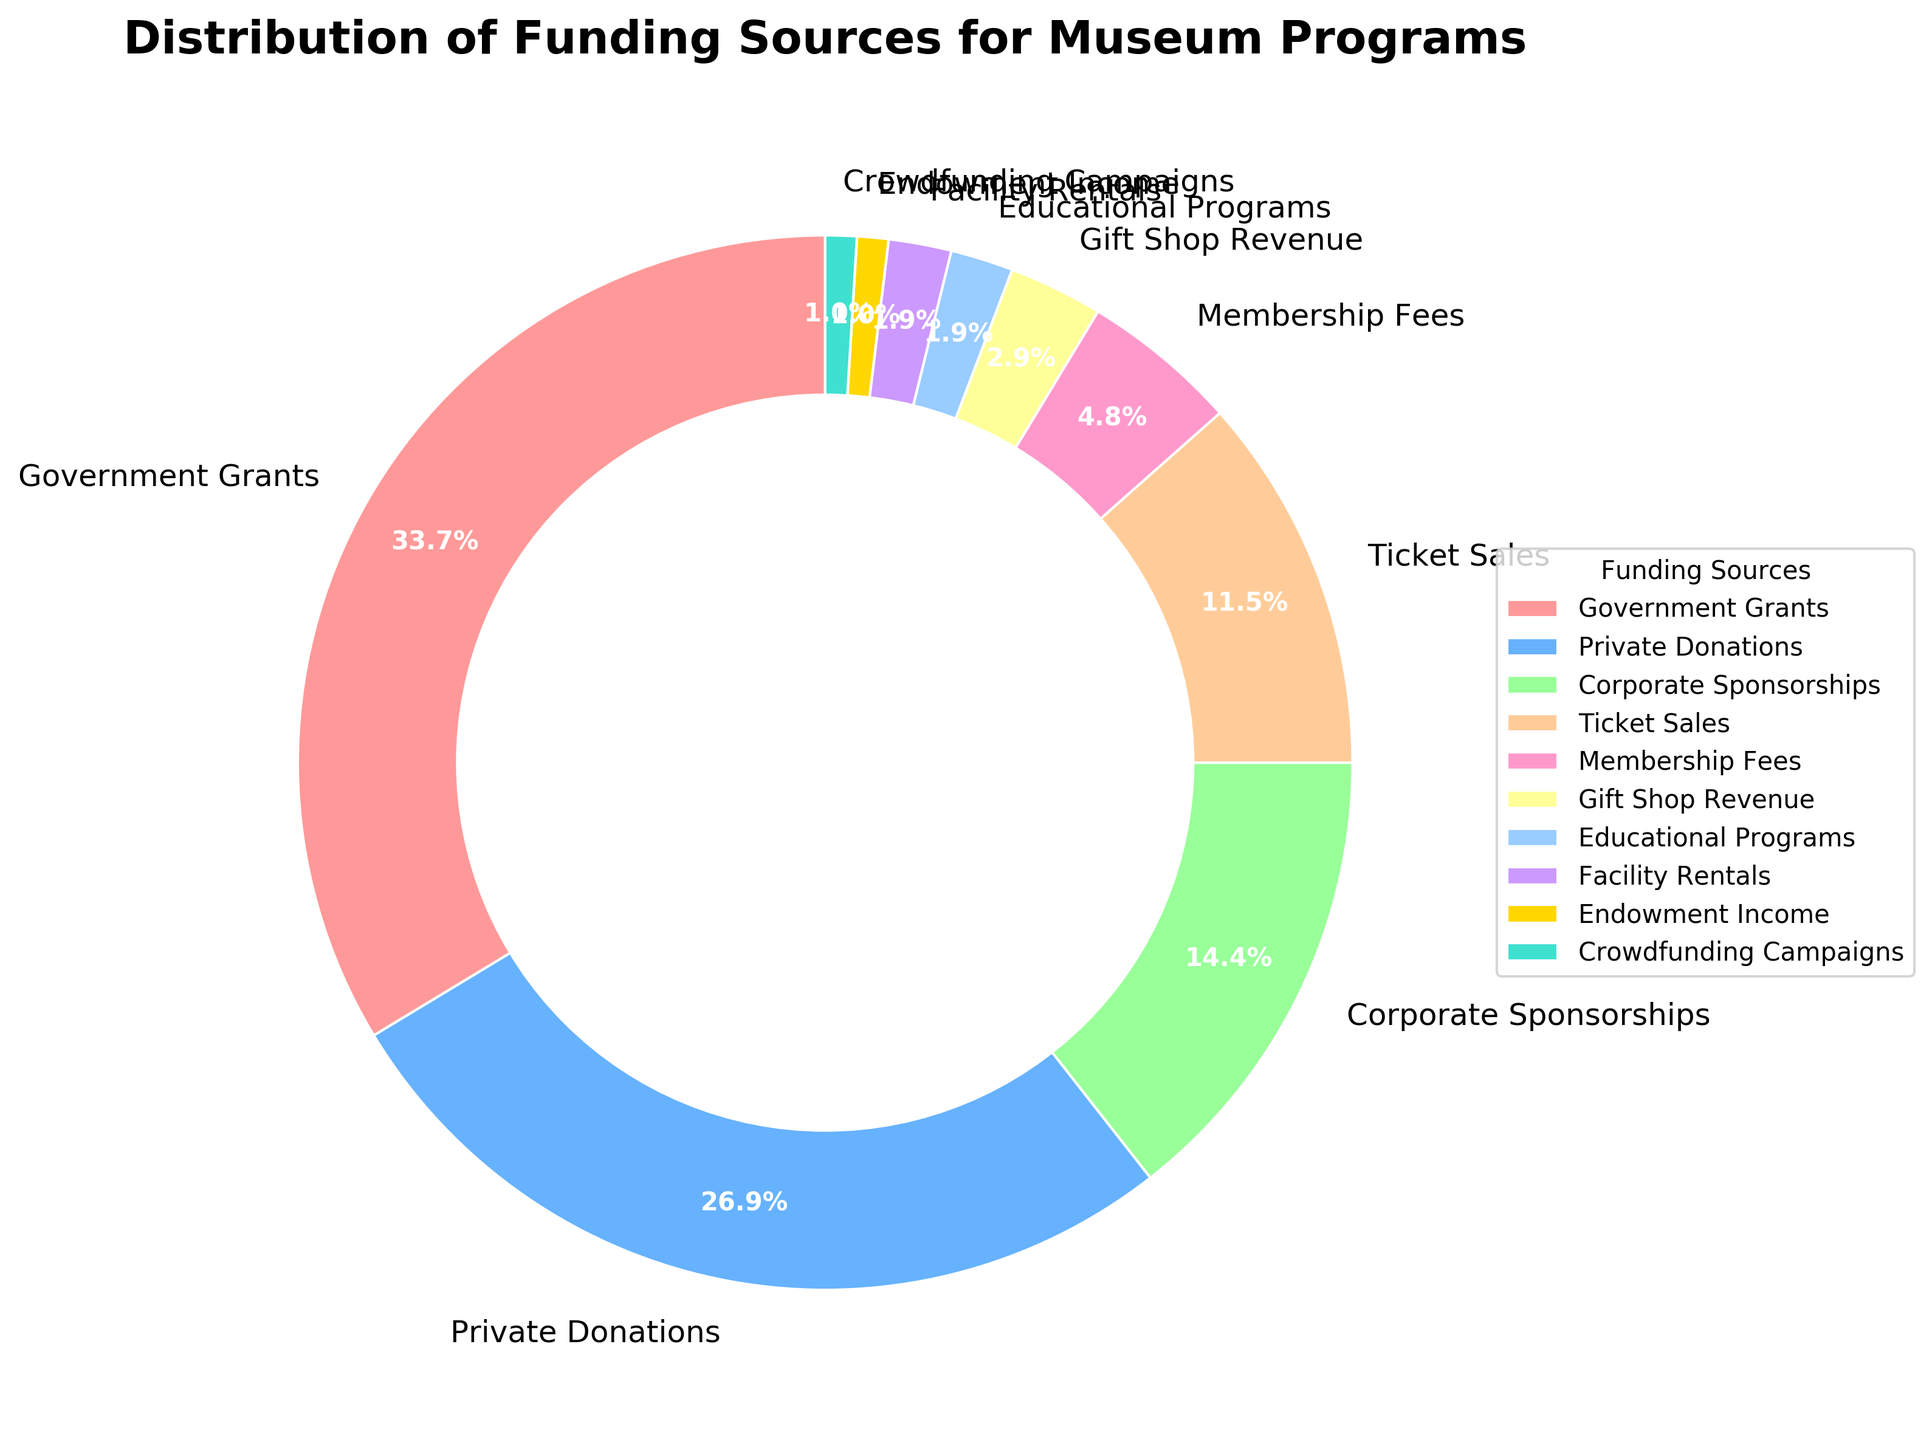What's the combined percentage of Government Grants and Private Donations? To find the combined percentage, add the percentages of Government Grants (35%) and Private Donations (28%). Thus, 35% + 28% = 63%.
Answer: 63% Which funding source contributes the least to the museum programs? By examining the pie chart, the smallest slice represents Crowdfunding Campaigns, which is 1%.
Answer: Crowdfunding Campaigns Are Ticket Sales contributing more or less than Membership Fees and Gift Shop Revenue combined? The percentage of Ticket Sales is 12%. The combined percentage of Membership Fees and Gift Shop Revenue is 5% + 3% = 8%. Since 12% is greater than 8%, Ticket Sales contribute more.
Answer: More Which funding source has a higher contribution, Corporate Sponsorships or Ticket Sales? Corporate Sponsorships contribute 15%, and Ticket Sales contribute 12%. Since 15% is greater than 12%, Corporate Sponsorships have a higher contribution.
Answer: Corporate Sponsorships What's the total percentage of funding coming from sources that provide less than 5% each? Sum the percentages of Gift Shop Revenue (3%), Educational Programs (2%), Facility Rentals (2%), Endowment Income (1%), and Crowdfunding Campaigns (1%). Thus, 3% + 2% + 2% + 1% + 1% = 9%.
Answer: 9% Is the sum of Private Donations and Corporate Sponsorships more than the Government Grants alone? Private Donations contribute 28%, and Corporate Sponsorships contribute 15%. Their combined contribution is 28% + 15% = 43%. Since Government Grants contribute 35%, 43% is more than 35%.
Answer: Yes What is the dominant funding source for the museum programs, and what percentage does it represent? The pie chart shows the largest slice for Government Grants, which is 35%.
Answer: Government Grants, 35% Compare the contributions of Corporate Sponsorships and the combined total of Educational Programs and Facility Rentals. Which is higher? Corporate Sponsorships contribute 15%. The combined total of Educational Programs and Facility Rentals is 2% + 2% = 4%. Since 15% is greater than 4%, Corporate Sponsorships have a higher contribution.
Answer: Corporate Sponsorships What is the difference in contribution percentages between the highest and the lowest funding sources? The highest is Government Grants with 35%, and the lowest are Endowment Income and Crowdfunding Campaigns, both with 1%. The difference is 35% - 1% = 34%.
Answer: 34% 